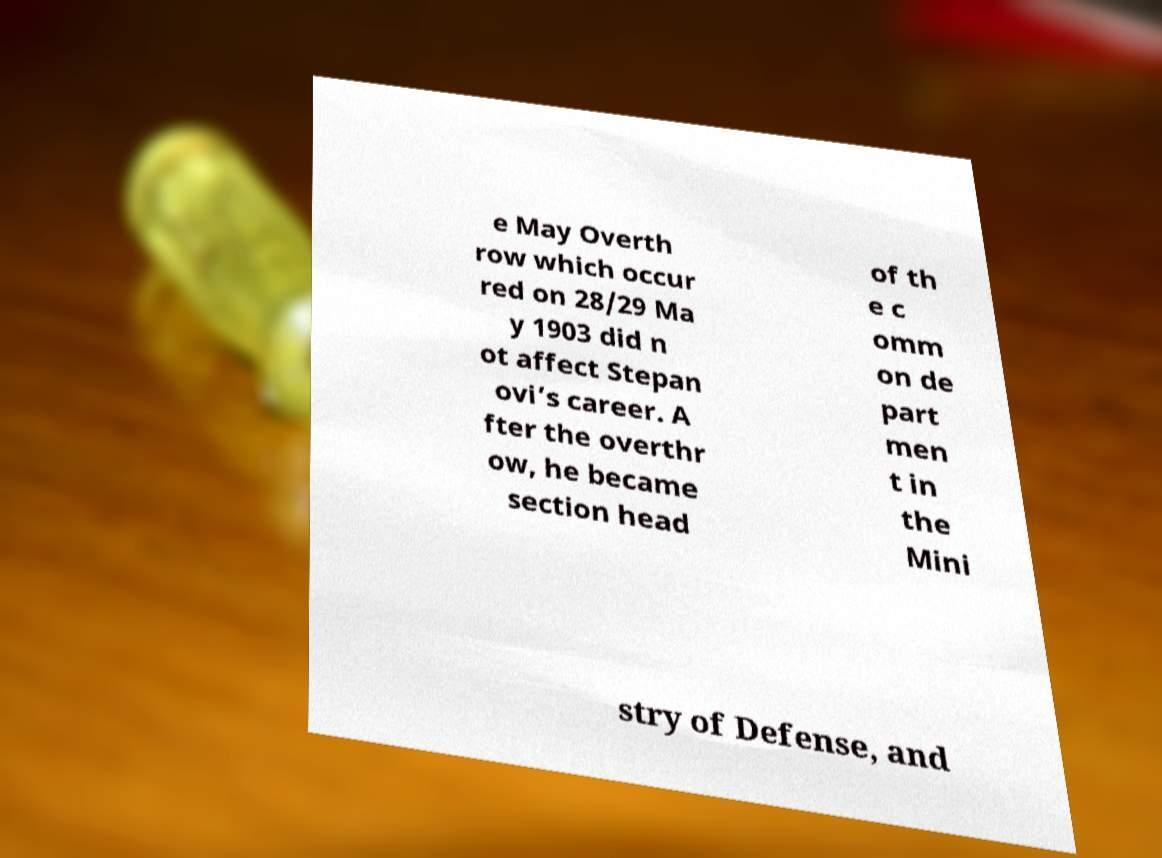Please read and relay the text visible in this image. What does it say? e May Overth row which occur red on 28/29 Ma y 1903 did n ot affect Stepan ovi’s career. A fter the overthr ow, he became section head of th e c omm on de part men t in the Mini stry of Defense, and 